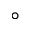<formula> <loc_0><loc_0><loc_500><loc_500>^ { \circ }</formula> 